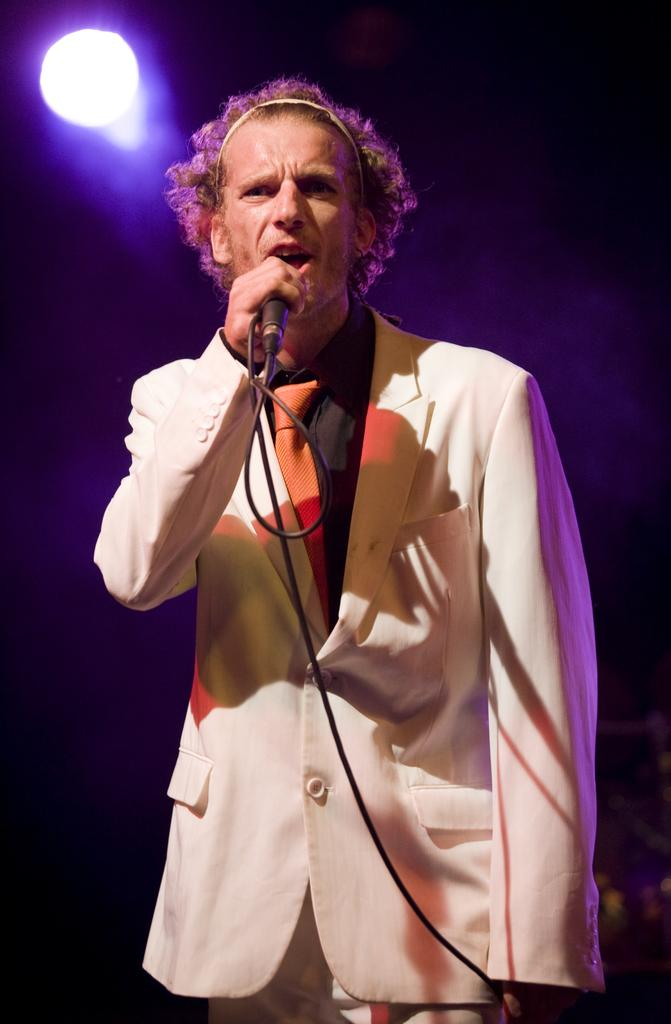Who is present in the image? There is a man in the image. What is the man doing in the image? The man is standing in the image. What is the man holding in the image? The man is holding a mic in the image. What is the man wearing in the image? The man is wearing a white suit and a tie in the image. What can be seen at the top of the image? There is a light at the top of the image. What type of animals can be seen at the zoo in the image? There is no zoo or animals present in the image; it features a man holding a mic and wearing a white suit. What type of juice is the man drinking in the image? There is no juice or drinking activity present in the image; the man is holding a mic. 